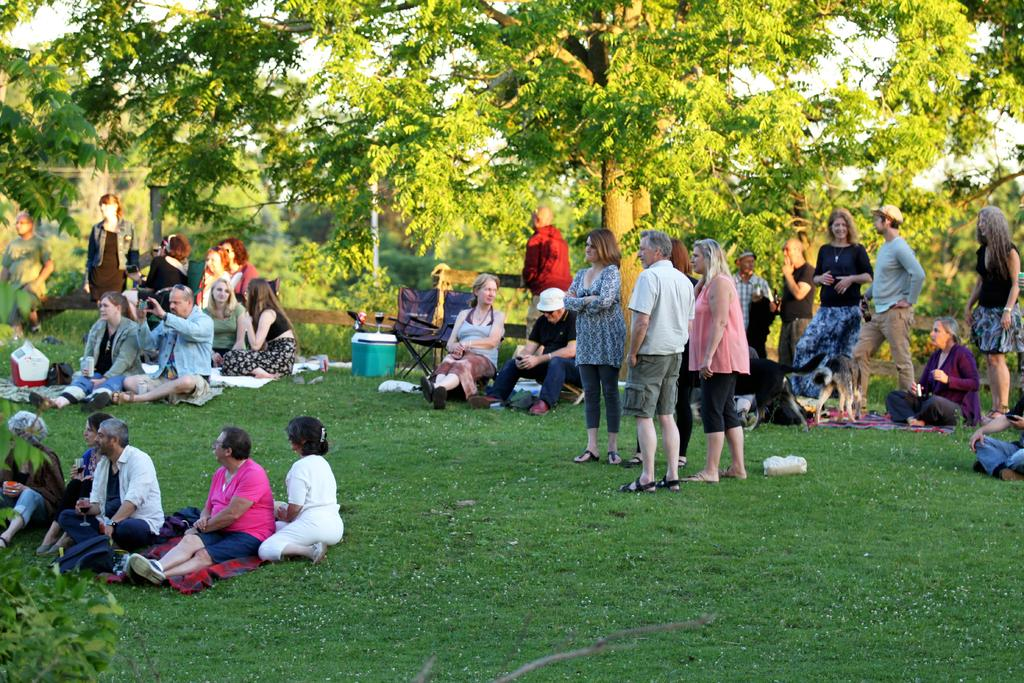How many people are in the image? There is a group of people in the image, but the exact number is not specified. What are the people in the image doing? Some people are standing, and some are sitting on the floor. What can be seen in the background of the image? There are trees in the background of the image. What type of toy is being stitched by the governor in the image? There is no governor or toy present in the image. 